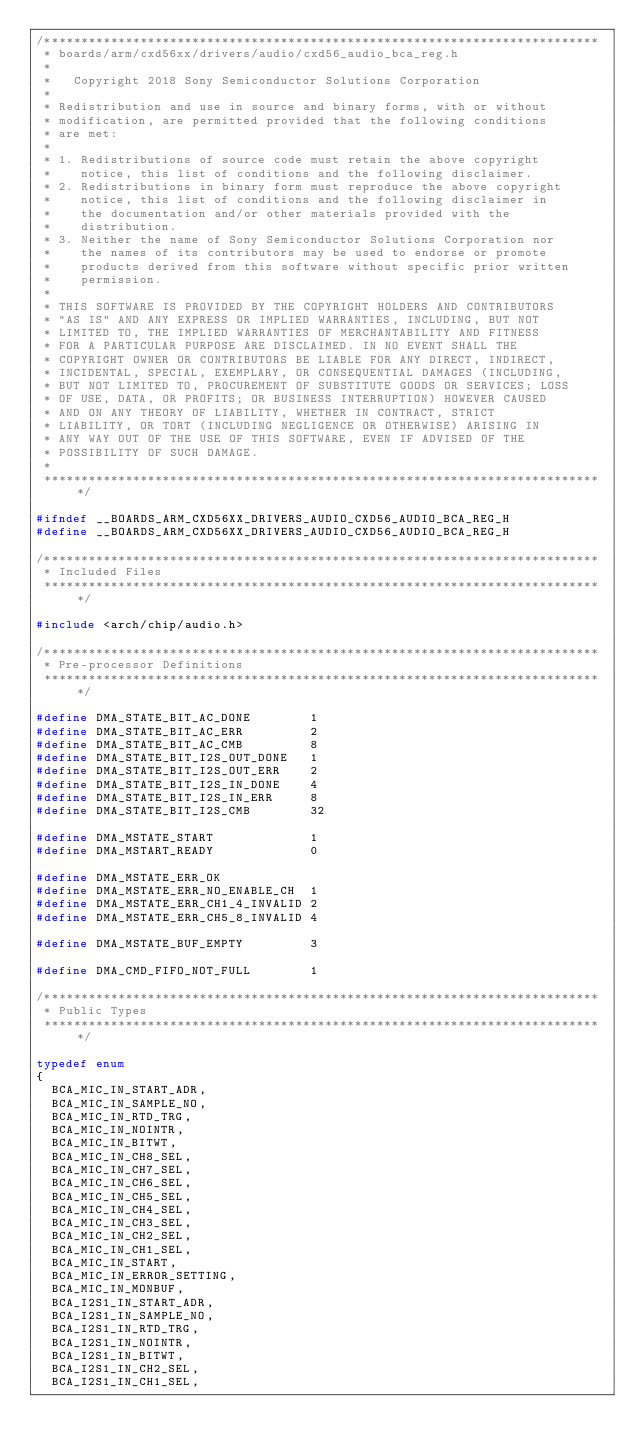<code> <loc_0><loc_0><loc_500><loc_500><_C_>/***************************************************************************
 * boards/arm/cxd56xx/drivers/audio/cxd56_audio_bca_reg.h
 *
 *   Copyright 2018 Sony Semiconductor Solutions Corporation
 *
 * Redistribution and use in source and binary forms, with or without
 * modification, are permitted provided that the following conditions
 * are met:
 *
 * 1. Redistributions of source code must retain the above copyright
 *    notice, this list of conditions and the following disclaimer.
 * 2. Redistributions in binary form must reproduce the above copyright
 *    notice, this list of conditions and the following disclaimer in
 *    the documentation and/or other materials provided with the
 *    distribution.
 * 3. Neither the name of Sony Semiconductor Solutions Corporation nor
 *    the names of its contributors may be used to endorse or promote
 *    products derived from this software without specific prior written
 *    permission.
 *
 * THIS SOFTWARE IS PROVIDED BY THE COPYRIGHT HOLDERS AND CONTRIBUTORS
 * "AS IS" AND ANY EXPRESS OR IMPLIED WARRANTIES, INCLUDING, BUT NOT
 * LIMITED TO, THE IMPLIED WARRANTIES OF MERCHANTABILITY AND FITNESS
 * FOR A PARTICULAR PURPOSE ARE DISCLAIMED. IN NO EVENT SHALL THE
 * COPYRIGHT OWNER OR CONTRIBUTORS BE LIABLE FOR ANY DIRECT, INDIRECT,
 * INCIDENTAL, SPECIAL, EXEMPLARY, OR CONSEQUENTIAL DAMAGES (INCLUDING,
 * BUT NOT LIMITED TO, PROCUREMENT OF SUBSTITUTE GOODS OR SERVICES; LOSS
 * OF USE, DATA, OR PROFITS; OR BUSINESS INTERRUPTION) HOWEVER CAUSED
 * AND ON ANY THEORY OF LIABILITY, WHETHER IN CONTRACT, STRICT
 * LIABILITY, OR TORT (INCLUDING NEGLIGENCE OR OTHERWISE) ARISING IN
 * ANY WAY OUT OF THE USE OF THIS SOFTWARE, EVEN IF ADVISED OF THE
 * POSSIBILITY OF SUCH DAMAGE.
 *
 ****************************************************************************/

#ifndef __BOARDS_ARM_CXD56XX_DRIVERS_AUDIO_CXD56_AUDIO_BCA_REG_H
#define __BOARDS_ARM_CXD56XX_DRIVERS_AUDIO_CXD56_AUDIO_BCA_REG_H

/***************************************************************************
 * Included Files
 ****************************************************************************/

#include <arch/chip/audio.h>

/***************************************************************************
 * Pre-processor Definitions
 ****************************************************************************/

#define DMA_STATE_BIT_AC_DONE        1
#define DMA_STATE_BIT_AC_ERR         2
#define DMA_STATE_BIT_AC_CMB         8
#define DMA_STATE_BIT_I2S_OUT_DONE   1
#define DMA_STATE_BIT_I2S_OUT_ERR    2
#define DMA_STATE_BIT_I2S_IN_DONE    4
#define DMA_STATE_BIT_I2S_IN_ERR     8
#define DMA_STATE_BIT_I2S_CMB        32

#define DMA_MSTATE_START             1
#define DMA_MSTART_READY             0

#define DMA_MSTATE_ERR_OK
#define DMA_MSTATE_ERR_NO_ENABLE_CH  1
#define DMA_MSTATE_ERR_CH1_4_INVALID 2
#define DMA_MSTATE_ERR_CH5_8_INVALID 4

#define DMA_MSTATE_BUF_EMPTY         3

#define DMA_CMD_FIFO_NOT_FULL        1

/***************************************************************************
 * Public Types
 ****************************************************************************/

typedef enum
{
  BCA_MIC_IN_START_ADR,
  BCA_MIC_IN_SAMPLE_NO,
  BCA_MIC_IN_RTD_TRG,
  BCA_MIC_IN_NOINTR,
  BCA_MIC_IN_BITWT,
  BCA_MIC_IN_CH8_SEL,
  BCA_MIC_IN_CH7_SEL,
  BCA_MIC_IN_CH6_SEL,
  BCA_MIC_IN_CH5_SEL,
  BCA_MIC_IN_CH4_SEL,
  BCA_MIC_IN_CH3_SEL,
  BCA_MIC_IN_CH2_SEL,
  BCA_MIC_IN_CH1_SEL,
  BCA_MIC_IN_START,
  BCA_MIC_IN_ERROR_SETTING,
  BCA_MIC_IN_MONBUF,
  BCA_I2S1_IN_START_ADR,
  BCA_I2S1_IN_SAMPLE_NO,
  BCA_I2S1_IN_RTD_TRG,
  BCA_I2S1_IN_NOINTR,
  BCA_I2S1_IN_BITWT,
  BCA_I2S1_IN_CH2_SEL,
  BCA_I2S1_IN_CH1_SEL,</code> 